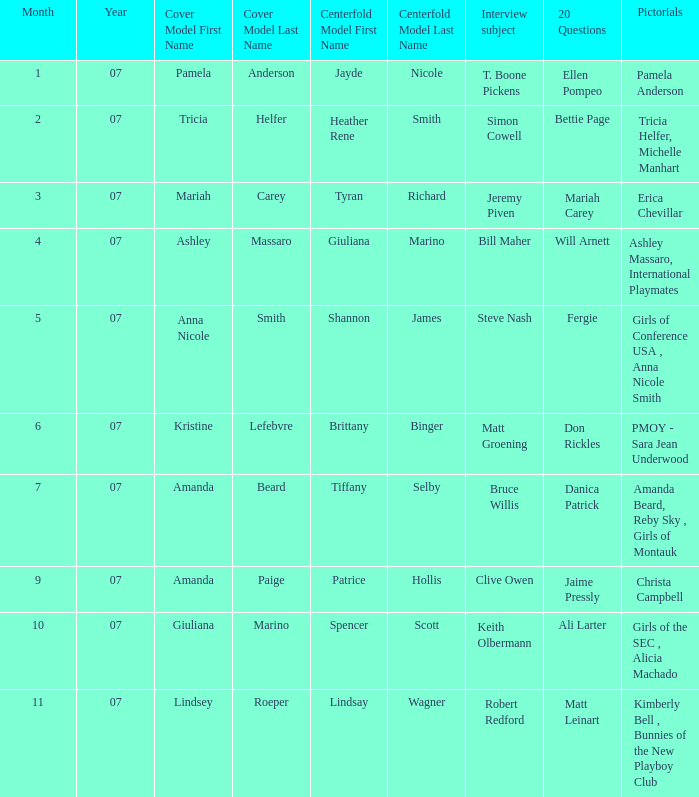Who was the centerfold model when the issue's pictorial was amanda beard, reby sky , girls of montauk ? Tiffany Selby. 